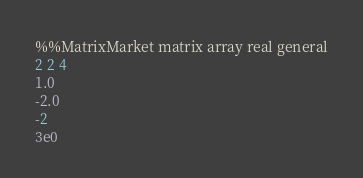<code> <loc_0><loc_0><loc_500><loc_500><_ObjectiveC_>%%MatrixMarket matrix array real general
2 2 4
1.0
-2.0
-2
3e0
</code> 